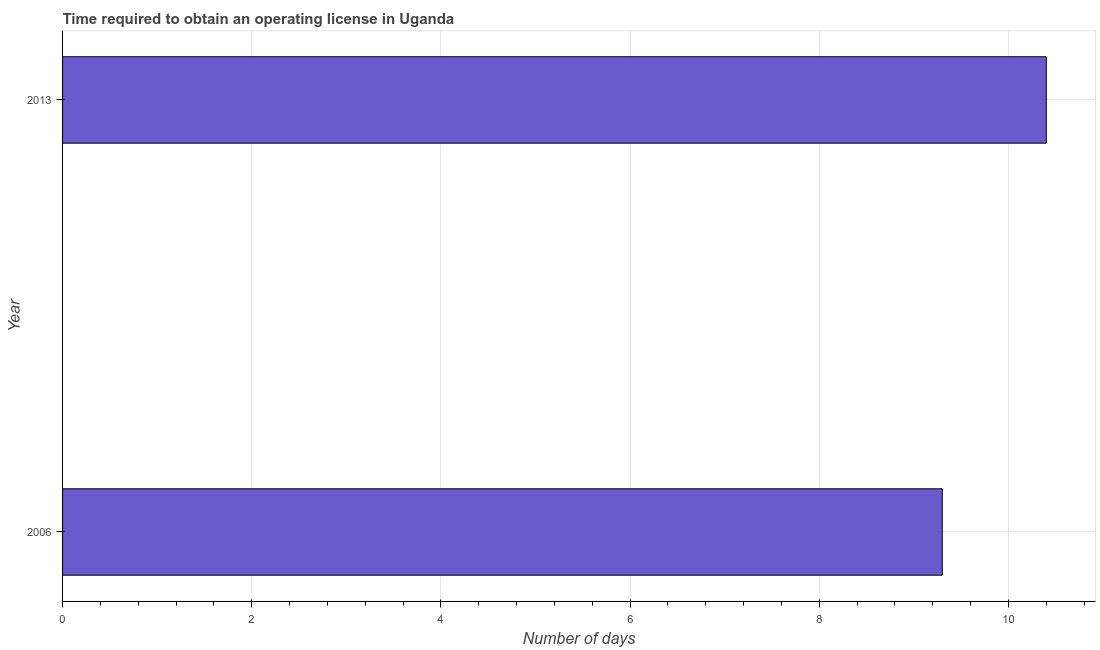Does the graph contain grids?
Make the answer very short. Yes. What is the title of the graph?
Offer a terse response. Time required to obtain an operating license in Uganda. What is the label or title of the X-axis?
Provide a succinct answer. Number of days. Across all years, what is the maximum number of days to obtain operating license?
Your response must be concise. 10.4. In which year was the number of days to obtain operating license maximum?
Provide a short and direct response. 2013. In which year was the number of days to obtain operating license minimum?
Provide a succinct answer. 2006. What is the sum of the number of days to obtain operating license?
Ensure brevity in your answer.  19.7. What is the difference between the number of days to obtain operating license in 2006 and 2013?
Keep it short and to the point. -1.1. What is the average number of days to obtain operating license per year?
Provide a succinct answer. 9.85. What is the median number of days to obtain operating license?
Keep it short and to the point. 9.85. In how many years, is the number of days to obtain operating license greater than 4.8 days?
Keep it short and to the point. 2. Do a majority of the years between 2006 and 2013 (inclusive) have number of days to obtain operating license greater than 2 days?
Your response must be concise. Yes. What is the ratio of the number of days to obtain operating license in 2006 to that in 2013?
Your answer should be compact. 0.89. In how many years, is the number of days to obtain operating license greater than the average number of days to obtain operating license taken over all years?
Make the answer very short. 1. How many bars are there?
Provide a short and direct response. 2. Are all the bars in the graph horizontal?
Your answer should be compact. Yes. How many years are there in the graph?
Offer a terse response. 2. Are the values on the major ticks of X-axis written in scientific E-notation?
Provide a succinct answer. No. What is the Number of days of 2006?
Ensure brevity in your answer.  9.3. What is the ratio of the Number of days in 2006 to that in 2013?
Offer a very short reply. 0.89. 